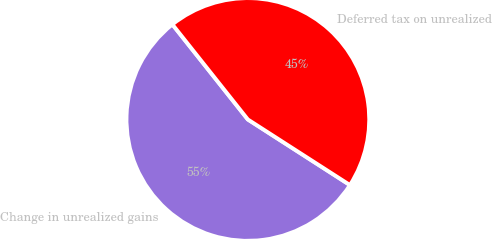Convert chart to OTSL. <chart><loc_0><loc_0><loc_500><loc_500><pie_chart><fcel>Change in unrealized gains<fcel>Deferred tax on unrealized<nl><fcel>55.23%<fcel>44.77%<nl></chart> 